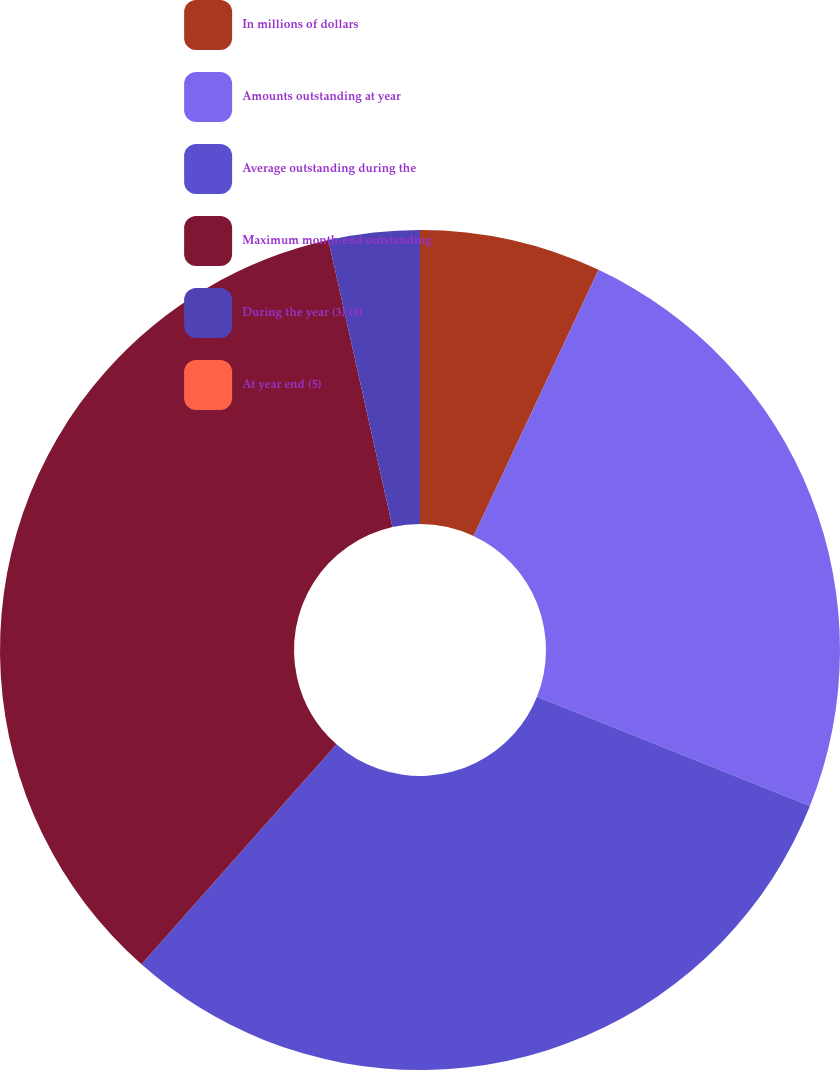Convert chart to OTSL. <chart><loc_0><loc_0><loc_500><loc_500><pie_chart><fcel>In millions of dollars<fcel>Amounts outstanding at year<fcel>Average outstanding during the<fcel>Maximum month-end outstanding<fcel>During the year (3) (4)<fcel>At year end (5)<nl><fcel>6.99%<fcel>24.07%<fcel>30.48%<fcel>34.96%<fcel>3.5%<fcel>0.0%<nl></chart> 